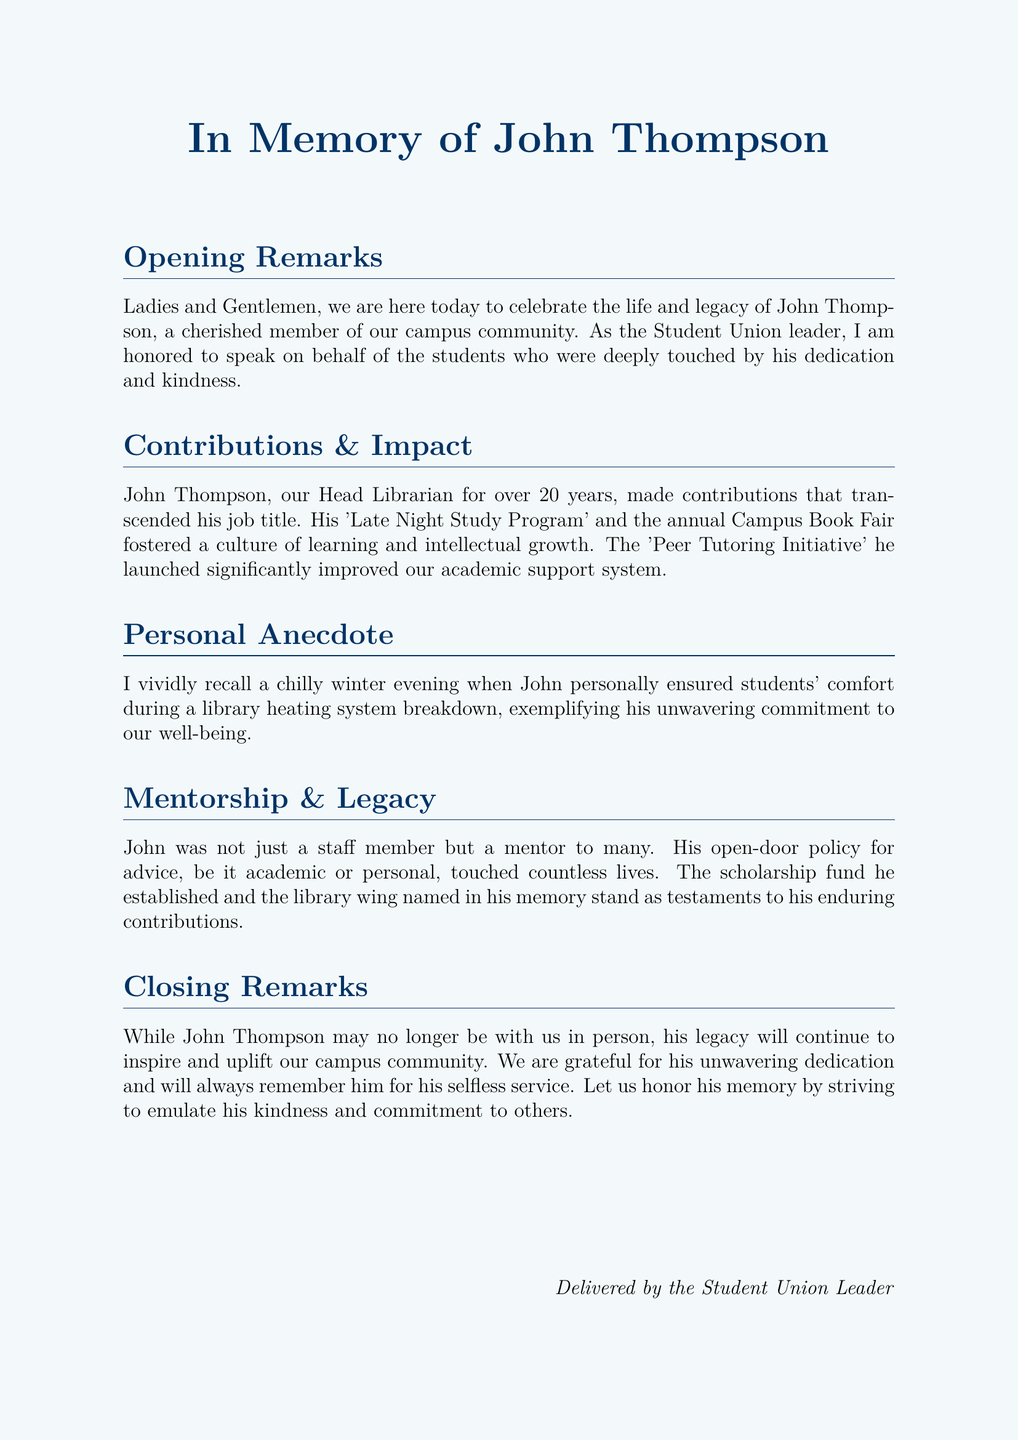What is the name of the staff member being remembered? The document is a eulogy for John Thompson, who is being commemorated for his contributions to the campus community.
Answer: John Thompson How many years did John serve as Head Librarian? The document states that John was the Head Librarian for over twenty years.
Answer: 20 years What program did John launch to improve academic support? The document mentions the 'Peer Tutoring Initiative' that John established to enhance academic help for students.
Answer: Peer Tutoring Initiative What was one of the personal gestures made by John during winter? The eulogy recounts a specific instance where John ensured students' comfort during a library heating system breakdown on a cold evening.
Answer: Comfort during heating system breakdown What is one of the lasting legacies mentioned in the eulogy? It describes that John established a scholarship fund and had a library wing named in his honor, indicating his long-lasting impact.
Answer: Scholarship fund What color is used for the document's page background? The background color is light blue, contributing to the overall soothing aesthetic of the eulogy document.
Answer: Light blue Which event did John organize annually to promote learning? The document states that John organized an annual Campus Book Fair to encourage reading and a culture of intellect.
Answer: Campus Book Fair What does the closing remark emphasize about John’s impact? The closing remarks stress that John's legacy will inspire and uplift the campus community, encouraging acts of kindness and dedication.
Answer: Inspiring and uplifting legacy 